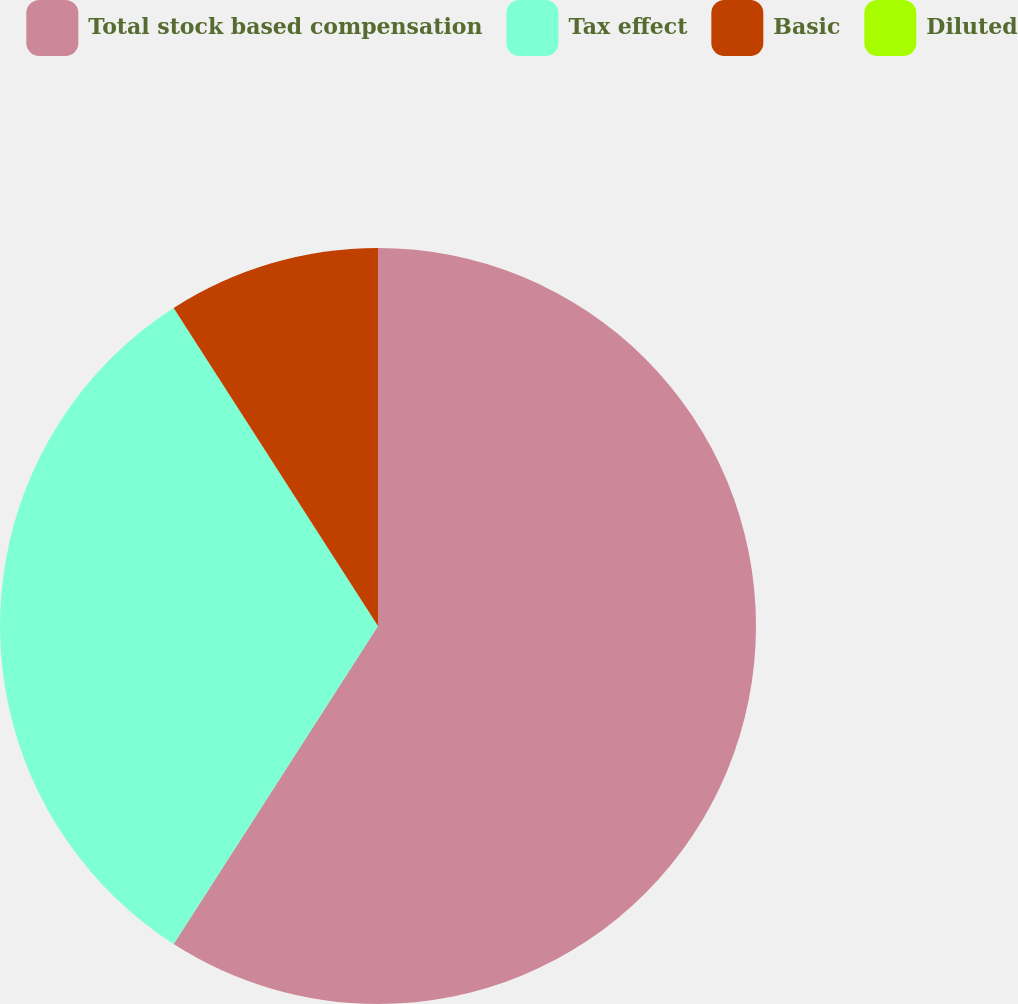Convert chart to OTSL. <chart><loc_0><loc_0><loc_500><loc_500><pie_chart><fcel>Total stock based compensation<fcel>Tax effect<fcel>Basic<fcel>Diluted<nl><fcel>59.09%<fcel>31.82%<fcel>9.09%<fcel>0.0%<nl></chart> 